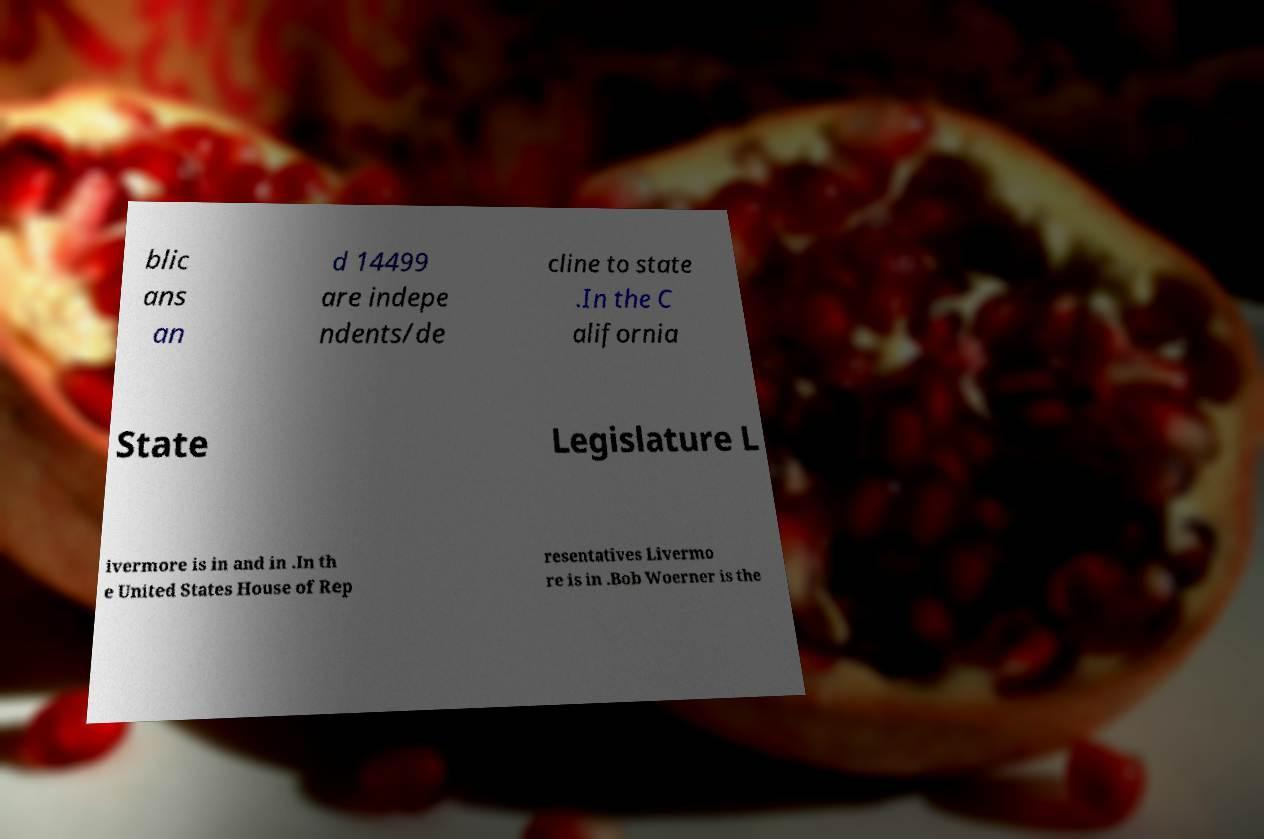For documentation purposes, I need the text within this image transcribed. Could you provide that? blic ans an d 14499 are indepe ndents/de cline to state .In the C alifornia State Legislature L ivermore is in and in .In th e United States House of Rep resentatives Livermo re is in .Bob Woerner is the 